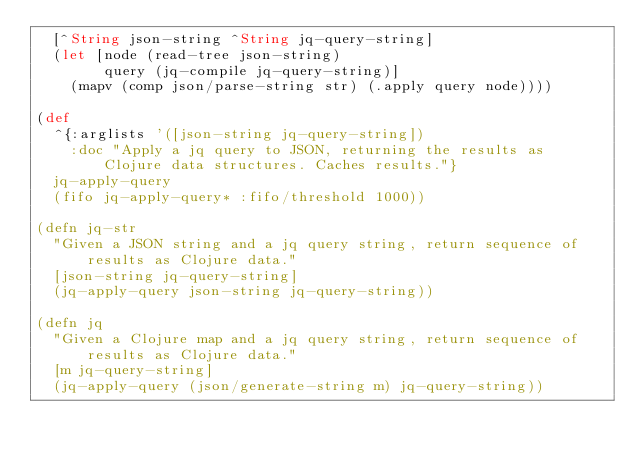<code> <loc_0><loc_0><loc_500><loc_500><_Clojure_>  [^String json-string ^String jq-query-string]
  (let [node (read-tree json-string)
        query (jq-compile jq-query-string)]
    (mapv (comp json/parse-string str) (.apply query node))))

(def
  ^{:arglists '([json-string jq-query-string])
    :doc "Apply a jq query to JSON, returning the results as Clojure data structures. Caches results."}
  jq-apply-query
  (fifo jq-apply-query* :fifo/threshold 1000))

(defn jq-str
  "Given a JSON string and a jq query string, return sequence of results as Clojure data."
  [json-string jq-query-string]
  (jq-apply-query json-string jq-query-string))

(defn jq
  "Given a Clojure map and a jq query string, return sequence of results as Clojure data."
  [m jq-query-string]
  (jq-apply-query (json/generate-string m) jq-query-string))
</code> 